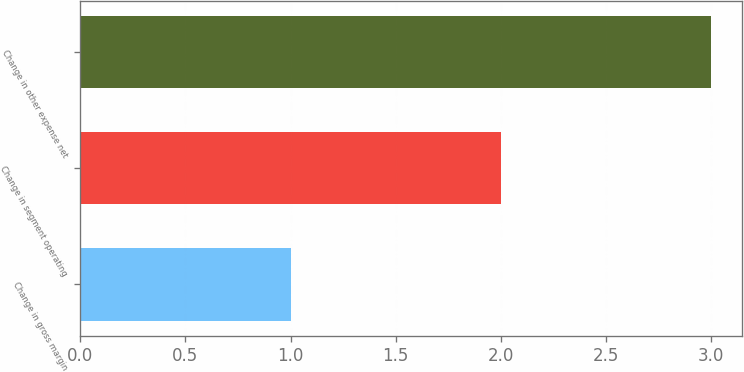Convert chart. <chart><loc_0><loc_0><loc_500><loc_500><bar_chart><fcel>Change in gross margin<fcel>Change in segment operating<fcel>Change in other expense net<nl><fcel>1<fcel>2<fcel>3<nl></chart> 